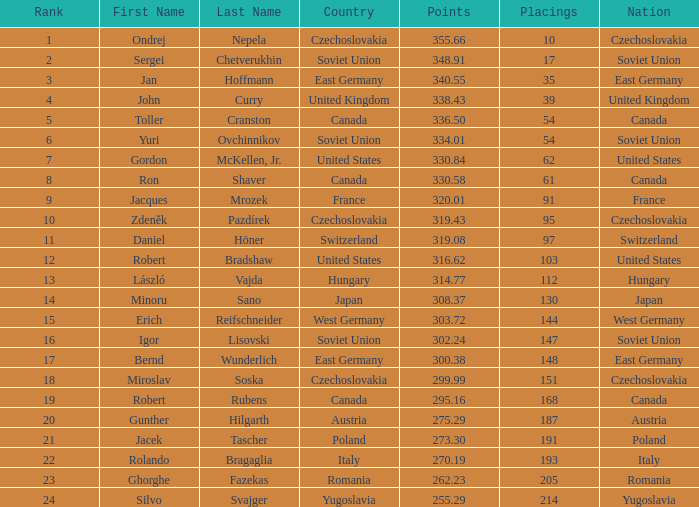What is the count of placings with points under 330.84 and having a name of silvo svajger? 1.0. 